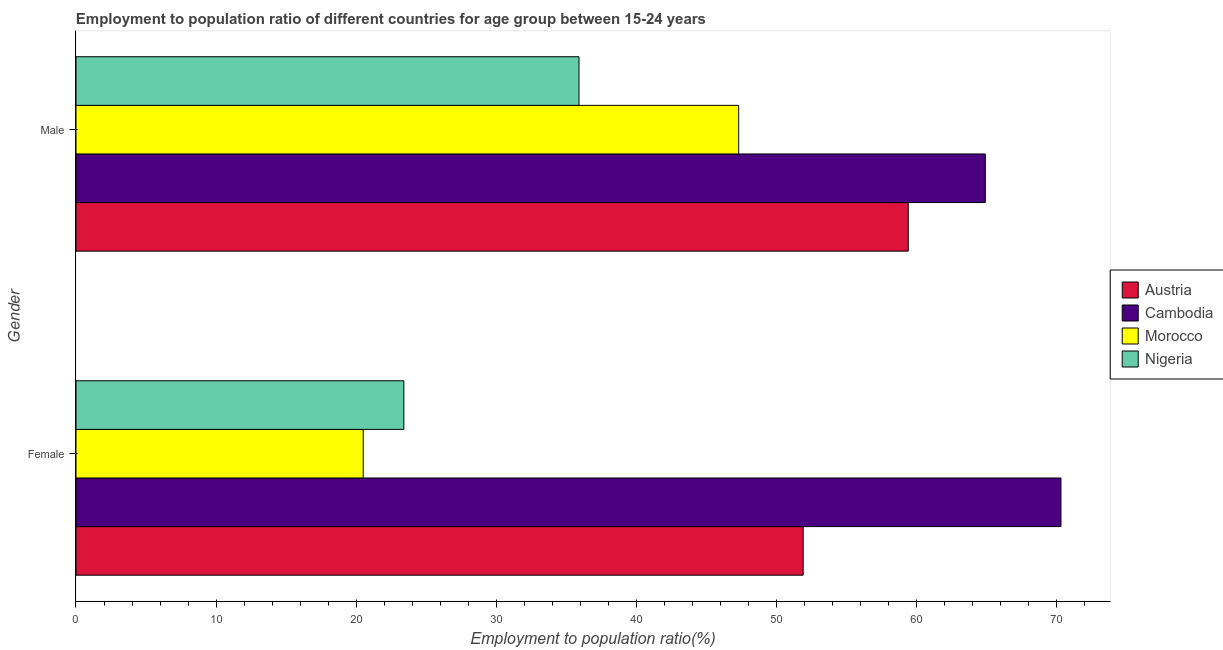How many different coloured bars are there?
Keep it short and to the point. 4. How many groups of bars are there?
Ensure brevity in your answer.  2. Are the number of bars per tick equal to the number of legend labels?
Make the answer very short. Yes. Are the number of bars on each tick of the Y-axis equal?
Your answer should be very brief. Yes. How many bars are there on the 2nd tick from the bottom?
Your response must be concise. 4. What is the employment to population ratio(male) in Morocco?
Your response must be concise. 47.3. Across all countries, what is the maximum employment to population ratio(female)?
Your answer should be compact. 70.3. In which country was the employment to population ratio(male) maximum?
Offer a terse response. Cambodia. In which country was the employment to population ratio(female) minimum?
Provide a short and direct response. Morocco. What is the total employment to population ratio(male) in the graph?
Your response must be concise. 207.5. What is the difference between the employment to population ratio(male) in Cambodia and that in Austria?
Provide a succinct answer. 5.5. What is the difference between the employment to population ratio(female) in Cambodia and the employment to population ratio(male) in Morocco?
Provide a short and direct response. 23. What is the average employment to population ratio(female) per country?
Offer a very short reply. 41.53. What is the difference between the employment to population ratio(male) and employment to population ratio(female) in Cambodia?
Make the answer very short. -5.4. In how many countries, is the employment to population ratio(female) greater than 32 %?
Keep it short and to the point. 2. What is the ratio of the employment to population ratio(male) in Nigeria to that in Cambodia?
Your response must be concise. 0.55. What does the 3rd bar from the bottom in Female represents?
Your response must be concise. Morocco. How many bars are there?
Give a very brief answer. 8. Are all the bars in the graph horizontal?
Ensure brevity in your answer.  Yes. What is the difference between two consecutive major ticks on the X-axis?
Your answer should be compact. 10. Are the values on the major ticks of X-axis written in scientific E-notation?
Give a very brief answer. No. Does the graph contain grids?
Your answer should be very brief. No. What is the title of the graph?
Offer a terse response. Employment to population ratio of different countries for age group between 15-24 years. What is the label or title of the X-axis?
Make the answer very short. Employment to population ratio(%). What is the label or title of the Y-axis?
Offer a very short reply. Gender. What is the Employment to population ratio(%) of Austria in Female?
Your answer should be very brief. 51.9. What is the Employment to population ratio(%) of Cambodia in Female?
Keep it short and to the point. 70.3. What is the Employment to population ratio(%) of Morocco in Female?
Your response must be concise. 20.5. What is the Employment to population ratio(%) in Nigeria in Female?
Offer a very short reply. 23.4. What is the Employment to population ratio(%) in Austria in Male?
Offer a very short reply. 59.4. What is the Employment to population ratio(%) in Cambodia in Male?
Your answer should be very brief. 64.9. What is the Employment to population ratio(%) in Morocco in Male?
Provide a succinct answer. 47.3. What is the Employment to population ratio(%) in Nigeria in Male?
Provide a succinct answer. 35.9. Across all Gender, what is the maximum Employment to population ratio(%) of Austria?
Provide a short and direct response. 59.4. Across all Gender, what is the maximum Employment to population ratio(%) in Cambodia?
Offer a terse response. 70.3. Across all Gender, what is the maximum Employment to population ratio(%) of Morocco?
Provide a succinct answer. 47.3. Across all Gender, what is the maximum Employment to population ratio(%) in Nigeria?
Your response must be concise. 35.9. Across all Gender, what is the minimum Employment to population ratio(%) of Austria?
Ensure brevity in your answer.  51.9. Across all Gender, what is the minimum Employment to population ratio(%) of Cambodia?
Give a very brief answer. 64.9. Across all Gender, what is the minimum Employment to population ratio(%) in Nigeria?
Offer a very short reply. 23.4. What is the total Employment to population ratio(%) of Austria in the graph?
Provide a succinct answer. 111.3. What is the total Employment to population ratio(%) of Cambodia in the graph?
Make the answer very short. 135.2. What is the total Employment to population ratio(%) in Morocco in the graph?
Provide a succinct answer. 67.8. What is the total Employment to population ratio(%) of Nigeria in the graph?
Give a very brief answer. 59.3. What is the difference between the Employment to population ratio(%) in Cambodia in Female and that in Male?
Give a very brief answer. 5.4. What is the difference between the Employment to population ratio(%) in Morocco in Female and that in Male?
Your answer should be very brief. -26.8. What is the difference between the Employment to population ratio(%) in Nigeria in Female and that in Male?
Make the answer very short. -12.5. What is the difference between the Employment to population ratio(%) of Austria in Female and the Employment to population ratio(%) of Morocco in Male?
Your response must be concise. 4.6. What is the difference between the Employment to population ratio(%) in Austria in Female and the Employment to population ratio(%) in Nigeria in Male?
Your answer should be compact. 16. What is the difference between the Employment to population ratio(%) of Cambodia in Female and the Employment to population ratio(%) of Nigeria in Male?
Give a very brief answer. 34.4. What is the difference between the Employment to population ratio(%) of Morocco in Female and the Employment to population ratio(%) of Nigeria in Male?
Give a very brief answer. -15.4. What is the average Employment to population ratio(%) of Austria per Gender?
Provide a succinct answer. 55.65. What is the average Employment to population ratio(%) in Cambodia per Gender?
Your answer should be very brief. 67.6. What is the average Employment to population ratio(%) in Morocco per Gender?
Offer a terse response. 33.9. What is the average Employment to population ratio(%) in Nigeria per Gender?
Give a very brief answer. 29.65. What is the difference between the Employment to population ratio(%) of Austria and Employment to population ratio(%) of Cambodia in Female?
Your answer should be compact. -18.4. What is the difference between the Employment to population ratio(%) of Austria and Employment to population ratio(%) of Morocco in Female?
Offer a terse response. 31.4. What is the difference between the Employment to population ratio(%) in Austria and Employment to population ratio(%) in Nigeria in Female?
Offer a very short reply. 28.5. What is the difference between the Employment to population ratio(%) of Cambodia and Employment to population ratio(%) of Morocco in Female?
Give a very brief answer. 49.8. What is the difference between the Employment to population ratio(%) in Cambodia and Employment to population ratio(%) in Nigeria in Female?
Your answer should be very brief. 46.9. What is the difference between the Employment to population ratio(%) of Austria and Employment to population ratio(%) of Cambodia in Male?
Make the answer very short. -5.5. What is the difference between the Employment to population ratio(%) in Austria and Employment to population ratio(%) in Nigeria in Male?
Offer a terse response. 23.5. What is the ratio of the Employment to population ratio(%) in Austria in Female to that in Male?
Your answer should be compact. 0.87. What is the ratio of the Employment to population ratio(%) in Cambodia in Female to that in Male?
Offer a terse response. 1.08. What is the ratio of the Employment to population ratio(%) of Morocco in Female to that in Male?
Ensure brevity in your answer.  0.43. What is the ratio of the Employment to population ratio(%) of Nigeria in Female to that in Male?
Provide a short and direct response. 0.65. What is the difference between the highest and the second highest Employment to population ratio(%) in Austria?
Give a very brief answer. 7.5. What is the difference between the highest and the second highest Employment to population ratio(%) of Morocco?
Ensure brevity in your answer.  26.8. What is the difference between the highest and the lowest Employment to population ratio(%) of Austria?
Keep it short and to the point. 7.5. What is the difference between the highest and the lowest Employment to population ratio(%) in Morocco?
Give a very brief answer. 26.8. 